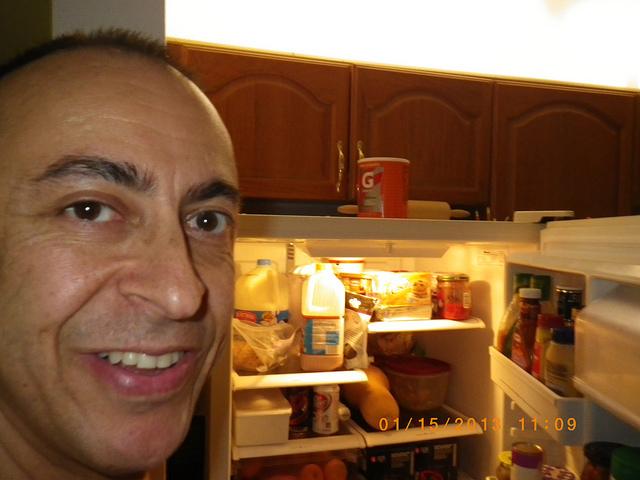Is the refrigerator light off?
Be succinct. No. Does the refrigerator full or empty?
Write a very short answer. Full. What color are the man's eyes?
Short answer required. Brown. Why is the refrigerator door open?
Concise answer only. To get food. 